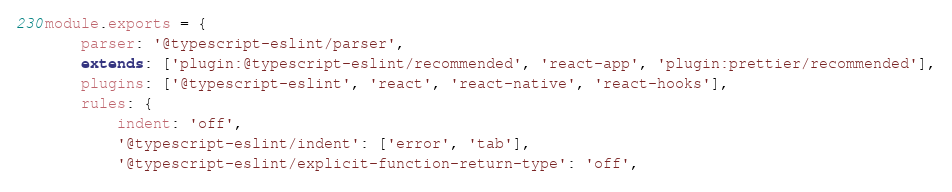<code> <loc_0><loc_0><loc_500><loc_500><_JavaScript_>module.exports = {
	parser: '@typescript-eslint/parser',
	extends: ['plugin:@typescript-eslint/recommended', 'react-app', 'plugin:prettier/recommended'],
	plugins: ['@typescript-eslint', 'react', 'react-native', 'react-hooks'],
	rules: {
		indent: 'off',
		'@typescript-eslint/indent': ['error', 'tab'],
		'@typescript-eslint/explicit-function-return-type': 'off',</code> 